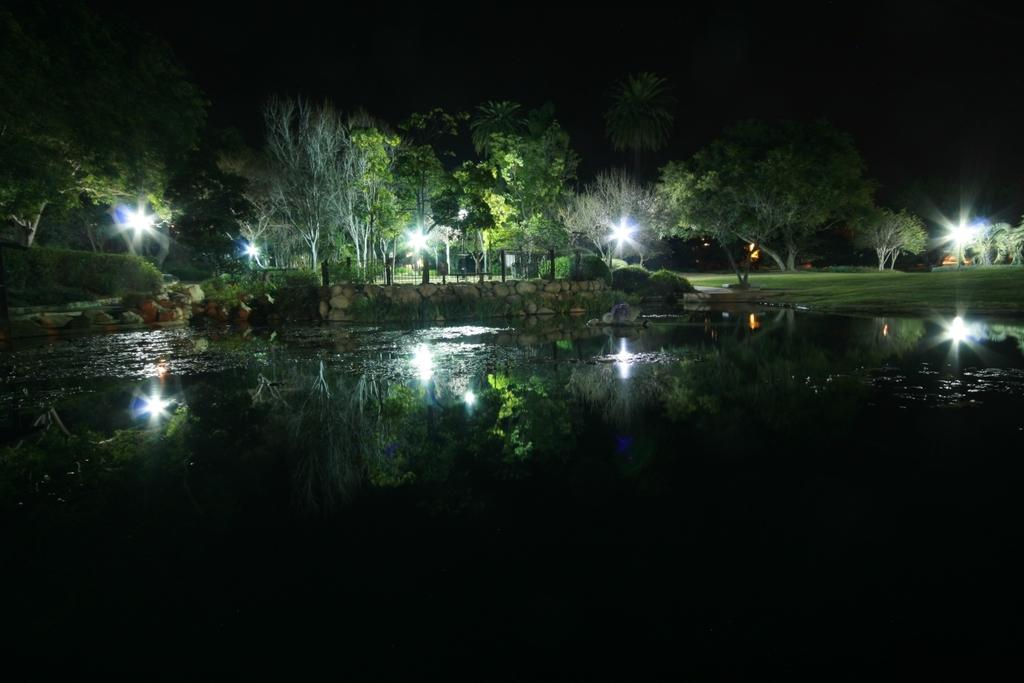What can be seen in the image that might be used for support or safety? There is a railing in the image that could be used for support or safety. What can be seen in the image that provides illumination? There are lights in the image that provide illumination. What type of vegetation is present in the image? There are trees and grass in the image. What other natural elements can be seen in the image? There are rocks and water in the image. How would you describe the sky in the image? The sky is dark in the image. What is the primary ground cover in the image? The land is covered with grass. Can you see a bead rolling down the railing in the image? There is no bead present in the image, so it cannot be seen rolling down the railing. Is there a tiger hiding among the trees in the image? There is no tiger present in the image; only trees, grass, rocks, and water are visible. 